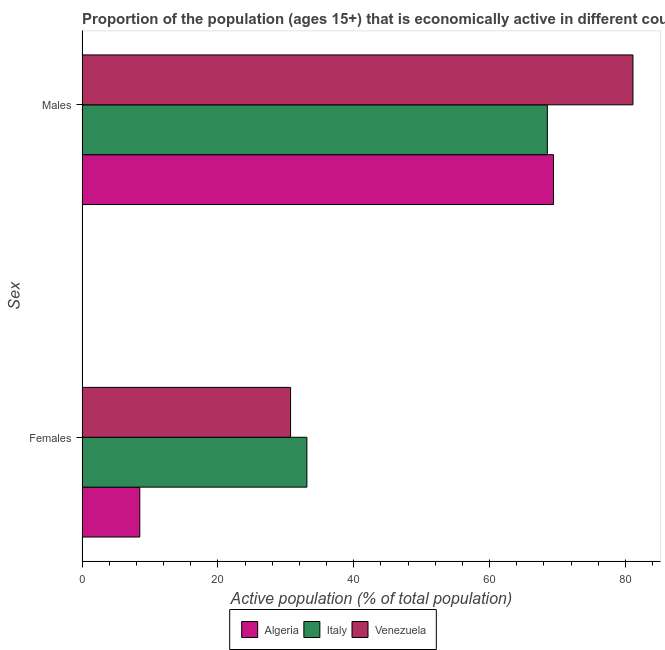How many different coloured bars are there?
Keep it short and to the point. 3. How many groups of bars are there?
Offer a very short reply. 2. What is the label of the 2nd group of bars from the top?
Provide a short and direct response. Females. What is the percentage of economically active male population in Italy?
Your response must be concise. 68.5. Across all countries, what is the maximum percentage of economically active male population?
Your answer should be very brief. 81.1. Across all countries, what is the minimum percentage of economically active male population?
Ensure brevity in your answer.  68.5. In which country was the percentage of economically active male population maximum?
Keep it short and to the point. Venezuela. What is the total percentage of economically active male population in the graph?
Provide a succinct answer. 219. What is the difference between the percentage of economically active female population in Venezuela and that in Algeria?
Your response must be concise. 22.2. What is the difference between the percentage of economically active female population in Italy and the percentage of economically active male population in Venezuela?
Offer a very short reply. -48. What is the average percentage of economically active female population per country?
Provide a succinct answer. 24.1. What is the difference between the percentage of economically active female population and percentage of economically active male population in Venezuela?
Your answer should be very brief. -50.4. In how many countries, is the percentage of economically active female population greater than 8 %?
Offer a very short reply. 3. What is the ratio of the percentage of economically active male population in Algeria to that in Italy?
Keep it short and to the point. 1.01. What does the 2nd bar from the top in Females represents?
Give a very brief answer. Italy. How many bars are there?
Provide a short and direct response. 6. Are all the bars in the graph horizontal?
Your answer should be very brief. Yes. How many countries are there in the graph?
Your response must be concise. 3. Are the values on the major ticks of X-axis written in scientific E-notation?
Your answer should be compact. No. Does the graph contain any zero values?
Keep it short and to the point. No. What is the title of the graph?
Offer a terse response. Proportion of the population (ages 15+) that is economically active in different countries. Does "Rwanda" appear as one of the legend labels in the graph?
Your answer should be compact. No. What is the label or title of the X-axis?
Make the answer very short. Active population (% of total population). What is the label or title of the Y-axis?
Make the answer very short. Sex. What is the Active population (% of total population) of Italy in Females?
Your answer should be compact. 33.1. What is the Active population (% of total population) of Venezuela in Females?
Offer a very short reply. 30.7. What is the Active population (% of total population) of Algeria in Males?
Give a very brief answer. 69.4. What is the Active population (% of total population) in Italy in Males?
Ensure brevity in your answer.  68.5. What is the Active population (% of total population) of Venezuela in Males?
Your answer should be compact. 81.1. Across all Sex, what is the maximum Active population (% of total population) of Algeria?
Make the answer very short. 69.4. Across all Sex, what is the maximum Active population (% of total population) in Italy?
Offer a very short reply. 68.5. Across all Sex, what is the maximum Active population (% of total population) in Venezuela?
Ensure brevity in your answer.  81.1. Across all Sex, what is the minimum Active population (% of total population) in Algeria?
Keep it short and to the point. 8.5. Across all Sex, what is the minimum Active population (% of total population) in Italy?
Provide a short and direct response. 33.1. Across all Sex, what is the minimum Active population (% of total population) in Venezuela?
Provide a short and direct response. 30.7. What is the total Active population (% of total population) of Algeria in the graph?
Give a very brief answer. 77.9. What is the total Active population (% of total population) in Italy in the graph?
Provide a short and direct response. 101.6. What is the total Active population (% of total population) in Venezuela in the graph?
Your answer should be compact. 111.8. What is the difference between the Active population (% of total population) in Algeria in Females and that in Males?
Offer a terse response. -60.9. What is the difference between the Active population (% of total population) in Italy in Females and that in Males?
Keep it short and to the point. -35.4. What is the difference between the Active population (% of total population) of Venezuela in Females and that in Males?
Provide a succinct answer. -50.4. What is the difference between the Active population (% of total population) of Algeria in Females and the Active population (% of total population) of Italy in Males?
Ensure brevity in your answer.  -60. What is the difference between the Active population (% of total population) in Algeria in Females and the Active population (% of total population) in Venezuela in Males?
Make the answer very short. -72.6. What is the difference between the Active population (% of total population) of Italy in Females and the Active population (% of total population) of Venezuela in Males?
Your response must be concise. -48. What is the average Active population (% of total population) in Algeria per Sex?
Offer a very short reply. 38.95. What is the average Active population (% of total population) of Italy per Sex?
Your answer should be very brief. 50.8. What is the average Active population (% of total population) of Venezuela per Sex?
Offer a very short reply. 55.9. What is the difference between the Active population (% of total population) in Algeria and Active population (% of total population) in Italy in Females?
Give a very brief answer. -24.6. What is the difference between the Active population (% of total population) of Algeria and Active population (% of total population) of Venezuela in Females?
Your answer should be very brief. -22.2. What is the difference between the Active population (% of total population) of Italy and Active population (% of total population) of Venezuela in Females?
Make the answer very short. 2.4. What is the difference between the Active population (% of total population) in Algeria and Active population (% of total population) in Venezuela in Males?
Keep it short and to the point. -11.7. What is the ratio of the Active population (% of total population) of Algeria in Females to that in Males?
Your response must be concise. 0.12. What is the ratio of the Active population (% of total population) in Italy in Females to that in Males?
Your answer should be compact. 0.48. What is the ratio of the Active population (% of total population) in Venezuela in Females to that in Males?
Make the answer very short. 0.38. What is the difference between the highest and the second highest Active population (% of total population) in Algeria?
Your response must be concise. 60.9. What is the difference between the highest and the second highest Active population (% of total population) in Italy?
Give a very brief answer. 35.4. What is the difference between the highest and the second highest Active population (% of total population) of Venezuela?
Offer a terse response. 50.4. What is the difference between the highest and the lowest Active population (% of total population) in Algeria?
Keep it short and to the point. 60.9. What is the difference between the highest and the lowest Active population (% of total population) in Italy?
Keep it short and to the point. 35.4. What is the difference between the highest and the lowest Active population (% of total population) in Venezuela?
Keep it short and to the point. 50.4. 